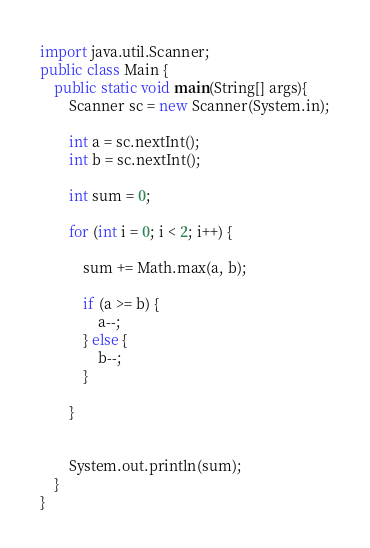<code> <loc_0><loc_0><loc_500><loc_500><_Java_>import java.util.Scanner;
public class Main {
	public static void main(String[] args){
		Scanner sc = new Scanner(System.in);
		
		int a = sc.nextInt();
		int b = sc.nextInt();
		
		int sum = 0;

		for (int i = 0; i < 2; i++) {
			
			sum += Math.max(a, b);
			
			if (a >= b) {
				a--;
			} else {
				b--;
			}
			
		}

		
		System.out.println(sum);
	}
}
</code> 